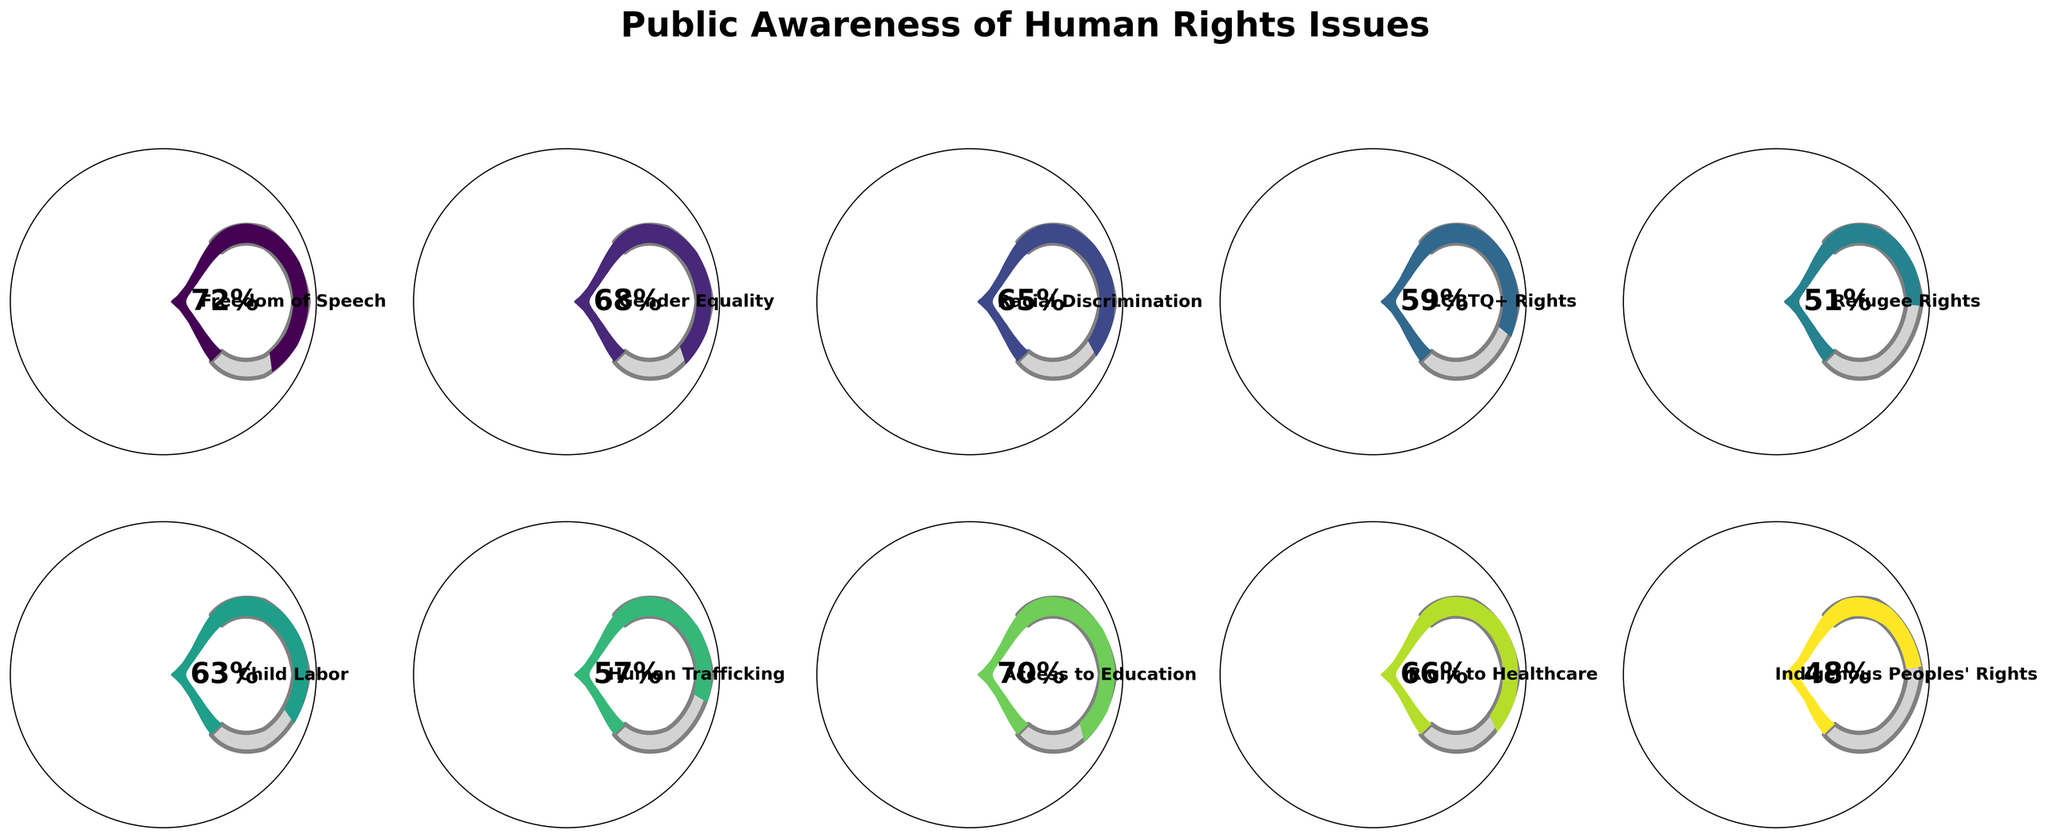What is the public awareness percentage for Gender Equality? Look for the Gauge Chart labeled "Gender Equality". The indicator points to the awareness percentage on the gauge.
Answer: 68% What is the title of the gauge chart figure? The title is written at the top of the figure, usually in a larger and bold font.
Answer: Public Awareness of Human Rights Issues Which human rights issue has the lowest public awareness percentage? Identify the gauge chart with the smallest percentage value.
Answer: Indigenous Peoples' Rights What is the average public awareness percentage across all the issues? Sum all the percentages and then divide by the number of issues. (72 + 68 + 65 + 59 + 51 + 63 + 57 + 70 + 66 + 48) / 10 = 61.9
Answer: 61.9 Which human rights issue has a public awareness percentage closest to 60%? Identify which gauge has a percentage closest to 60%.
Answer: LGBTQ+ Rights How many topics have a public awareness percentage greater than 65%? Count the number of gauge charts where the indicator shows a percentage higher than 65.
Answer: 5 What is the difference in public awareness percentage between Freedom of Speech and Refugee Rights? Subtract the percentage of Refugee Rights from the percentage of Freedom of Speech. 72 - 51 = 21
Answer: 21 Is the public awareness of Access to Education higher or lower than Right to Healthcare? Compare the percentages shown on the respective gauge charts.
Answer: Higher Which human rights issue shows a public awareness of 57%? Look for the gauge chart with the indicator showing 57%.
Answer: Human Trafficking What is the median public awareness percentage of all the issues? Arrange the percentages in ascending order: (48, 51, 57, 59, 63, 65, 66, 68, 70, 72). The median is the average of the 5th and 6th values. (63 + 65) / 2 = 64
Answer: 64 